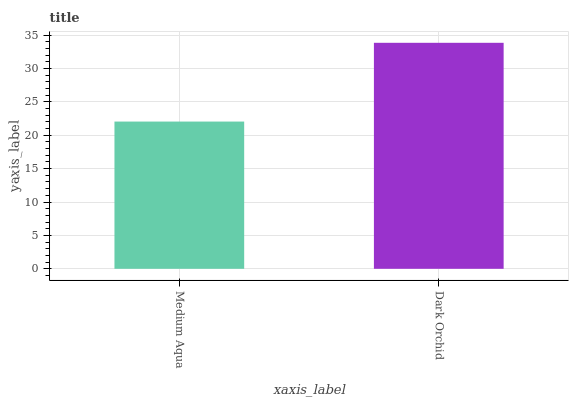Is Medium Aqua the minimum?
Answer yes or no. Yes. Is Dark Orchid the maximum?
Answer yes or no. Yes. Is Dark Orchid the minimum?
Answer yes or no. No. Is Dark Orchid greater than Medium Aqua?
Answer yes or no. Yes. Is Medium Aqua less than Dark Orchid?
Answer yes or no. Yes. Is Medium Aqua greater than Dark Orchid?
Answer yes or no. No. Is Dark Orchid less than Medium Aqua?
Answer yes or no. No. Is Dark Orchid the high median?
Answer yes or no. Yes. Is Medium Aqua the low median?
Answer yes or no. Yes. Is Medium Aqua the high median?
Answer yes or no. No. Is Dark Orchid the low median?
Answer yes or no. No. 